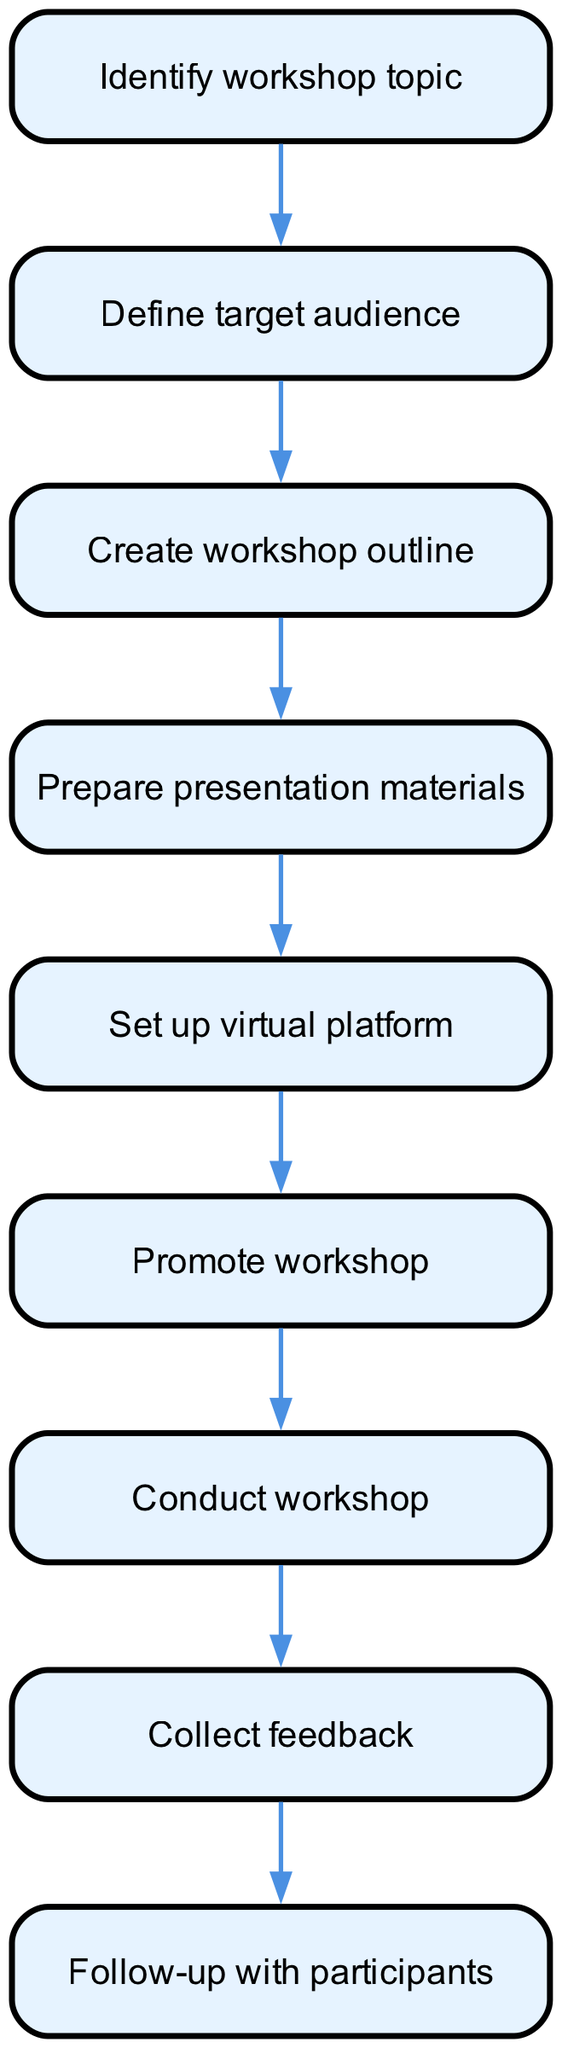What is the first step in the workflow? The first step is identified by the initial node in the diagram, which is labeled "Identify workshop topic."
Answer: Identify workshop topic How many nodes are present in the diagram? The total number of nodes is counted by summing all distinct steps listed in the diagram, which are nine in total.
Answer: Nine What is the last step in the workflow? The last step can be identified by looking at the final node in the sequence, which is labeled "Follow-up with participants."
Answer: Follow-up with participants Which node directly follows "Conduct workshop"? To find this, we look for the edge that starts from the node labeled "Conduct workshop," leading directly to the next node, which is "Collect feedback."
Answer: Collect feedback Is "Set up virtual platform" followed by any other steps? To answer this, we check if there is an outgoing edge from "Set up virtual platform." Since it connects to "Promote workshop," it confirms that it is indeed followed by another step.
Answer: Yes How many edges connect the nodes in the workflow? The number of edges is determined by counting the connections made between the nodes, which total eight in the diagram.
Answer: Eight What is the relationship between "Define target audience" and "Create workshop outline"? The relationship is established through a direct edge connecting "Define target audience" to "Create workshop outline," indicating a sequential flow from the first to the second.
Answer: Sequential flow Which step comes after "Promote workshop"? By examining the connection from "Promote workshop," the next node it leads to is "Conduct workshop," indicating this is the immediate subsequent step.
Answer: Conduct workshop What is a key action taken after the workshop is conducted? To find this, we look for the action that occurs directly after "Conduct workshop," which is to "Collect feedback," emphasizing the importance of gathering participant insights.
Answer: Collect feedback 